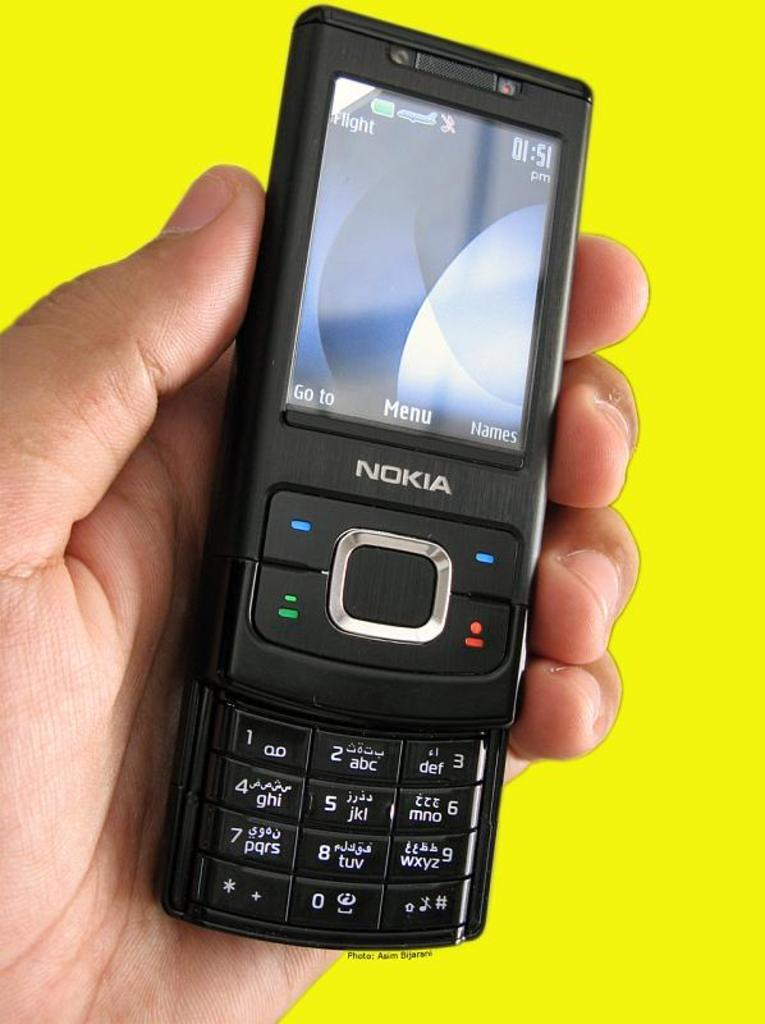<image>
Present a compact description of the photo's key features. A close up of an old black Nokia phone showing the time as 01.51 